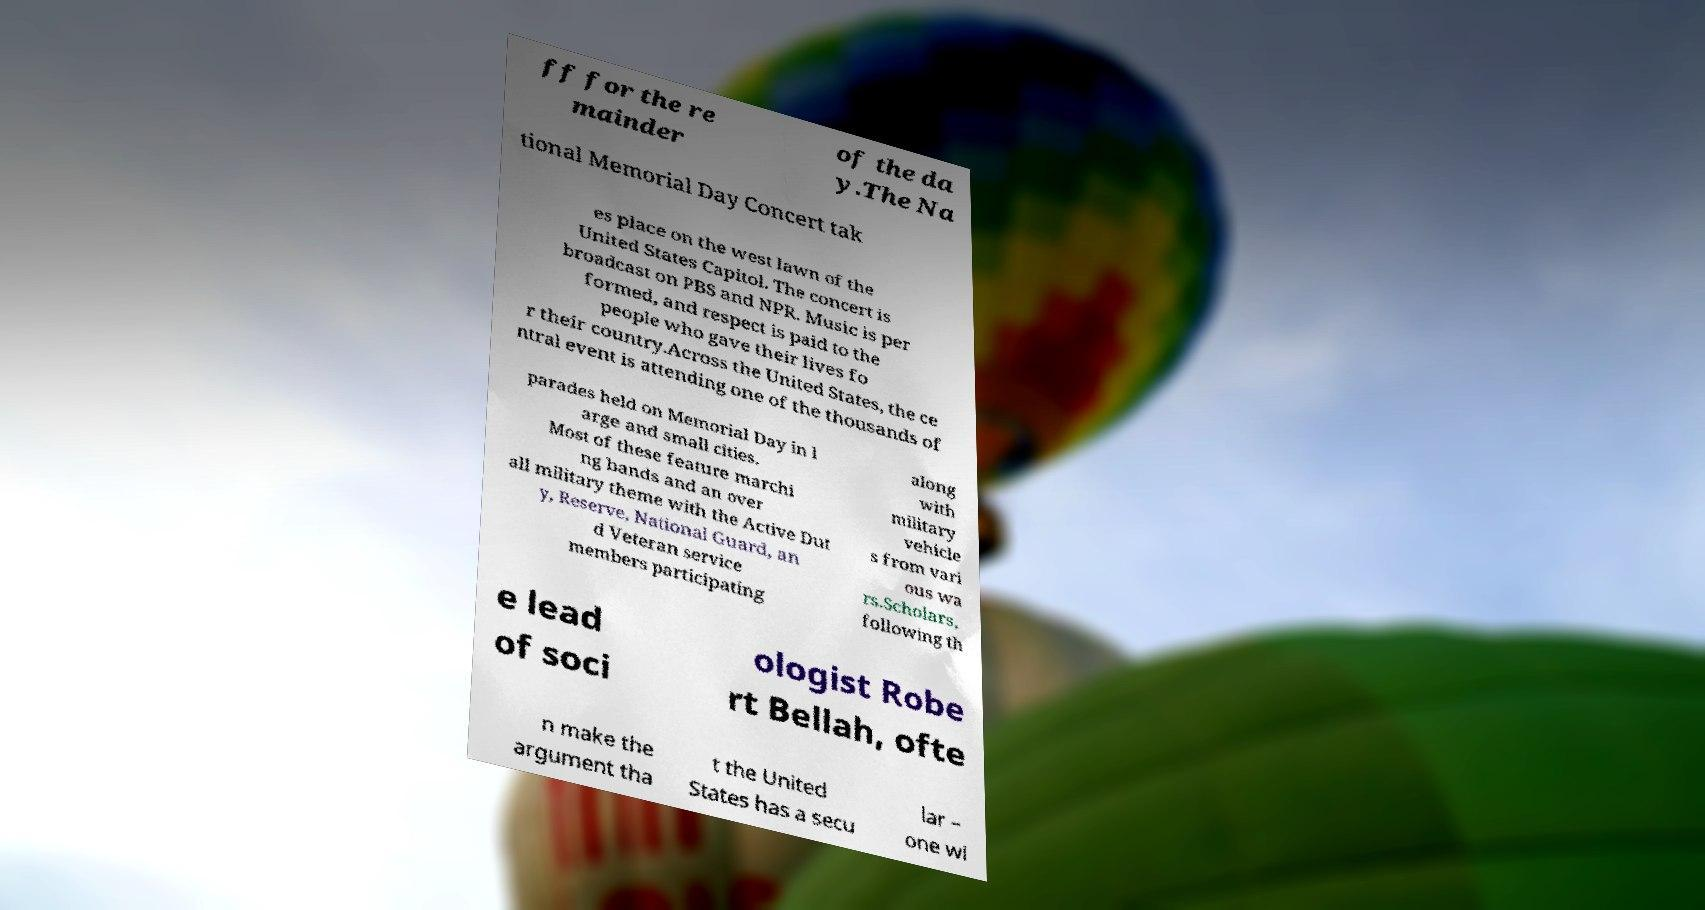I need the written content from this picture converted into text. Can you do that? ff for the re mainder of the da y.The Na tional Memorial Day Concert tak es place on the west lawn of the United States Capitol. The concert is broadcast on PBS and NPR. Music is per formed, and respect is paid to the people who gave their lives fo r their country.Across the United States, the ce ntral event is attending one of the thousands of parades held on Memorial Day in l arge and small cities. Most of these feature marchi ng bands and an over all military theme with the Active Dut y, Reserve, National Guard, an d Veteran service members participating along with military vehicle s from vari ous wa rs.Scholars, following th e lead of soci ologist Robe rt Bellah, ofte n make the argument tha t the United States has a secu lar – one wi 